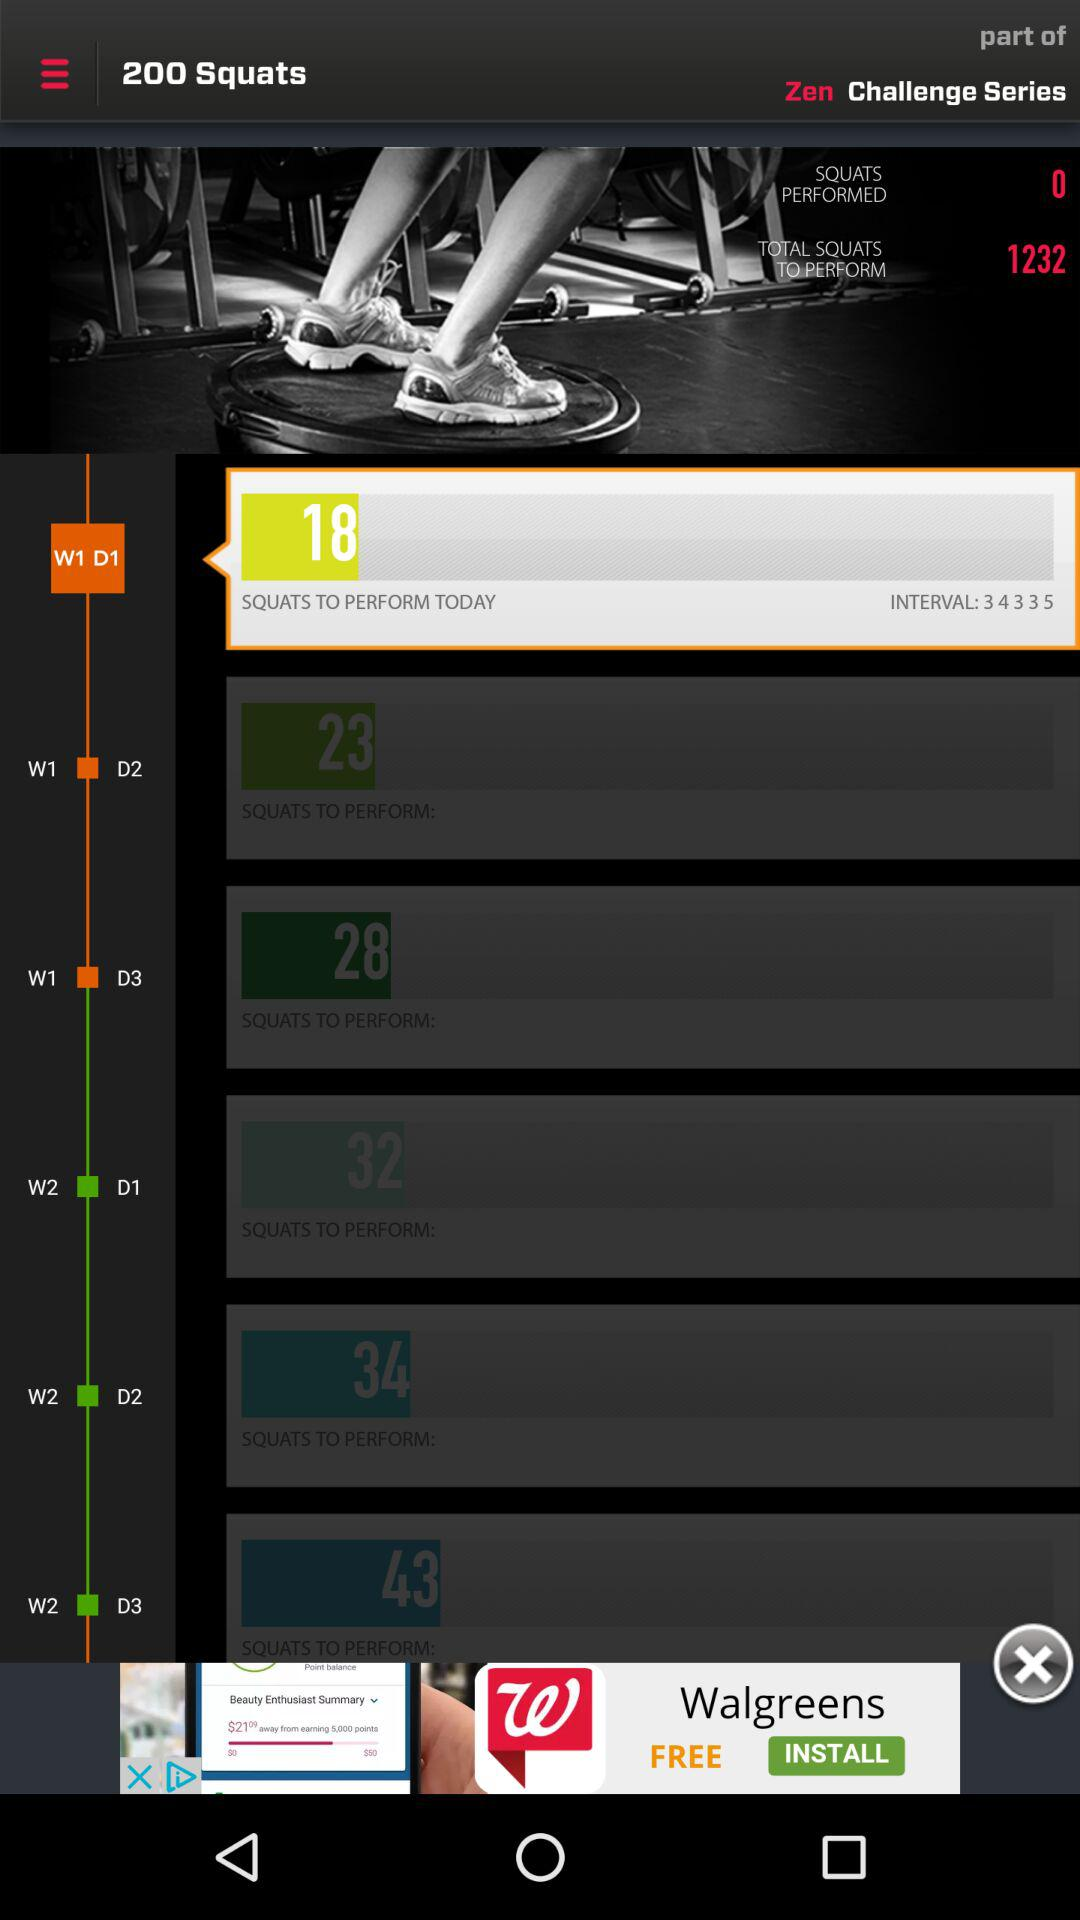How many squats in total are to be performed on Day 1 of Week 1? The total number of squats to be performed on Day 1 of Week 1 is 18. 